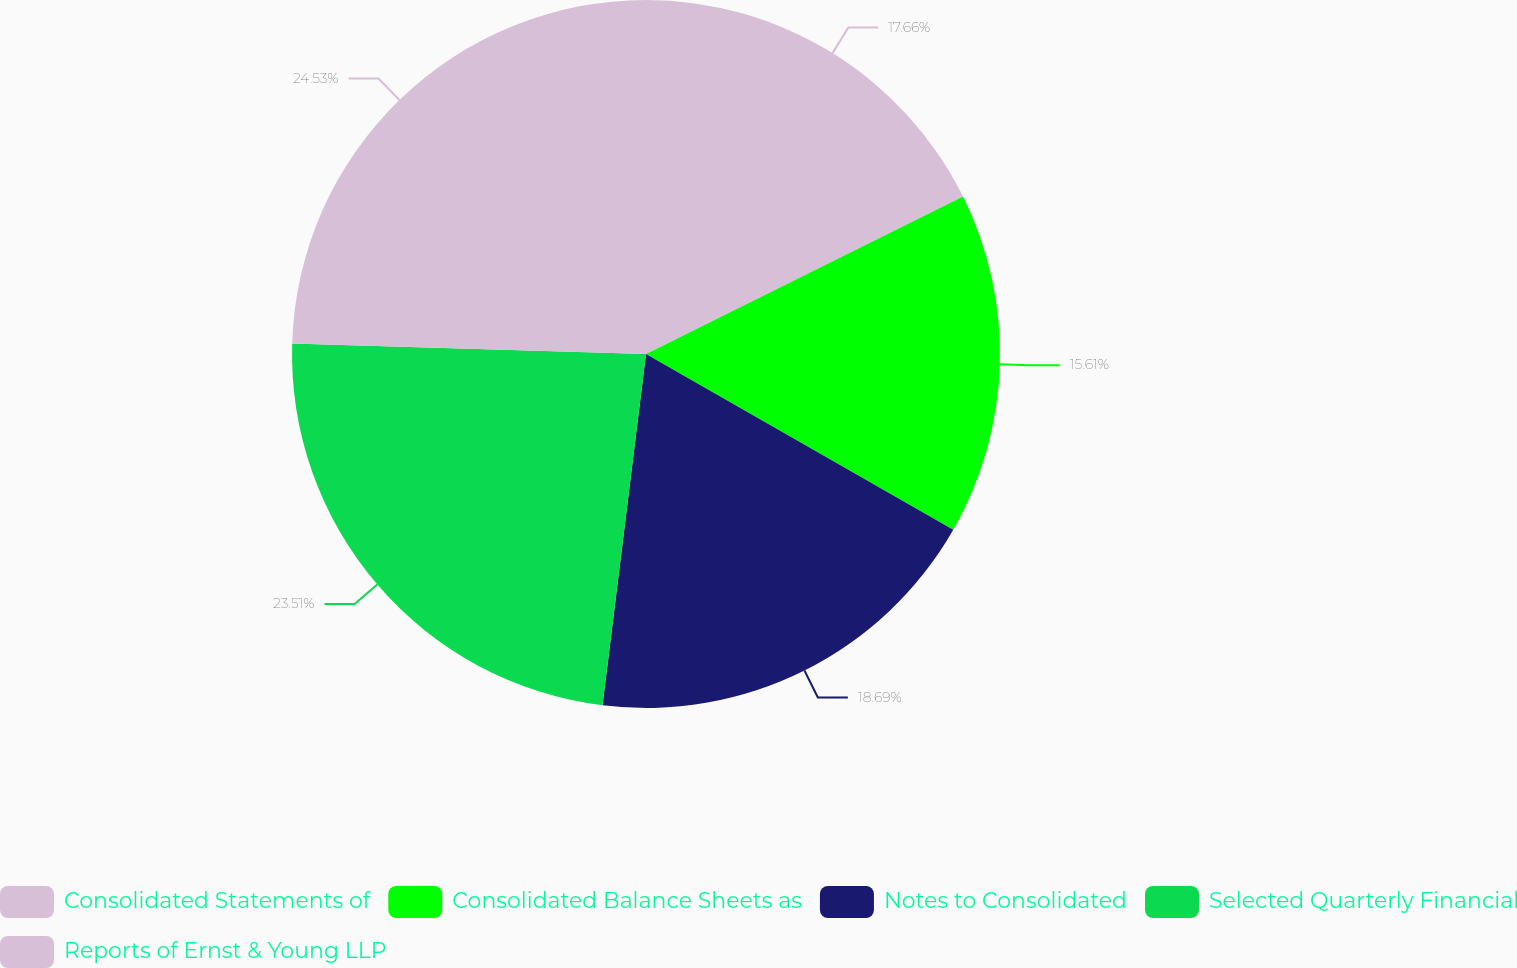<chart> <loc_0><loc_0><loc_500><loc_500><pie_chart><fcel>Consolidated Statements of<fcel>Consolidated Balance Sheets as<fcel>Notes to Consolidated<fcel>Selected Quarterly Financial<fcel>Reports of Ernst & Young LLP<nl><fcel>17.66%<fcel>15.61%<fcel>18.69%<fcel>23.51%<fcel>24.53%<nl></chart> 